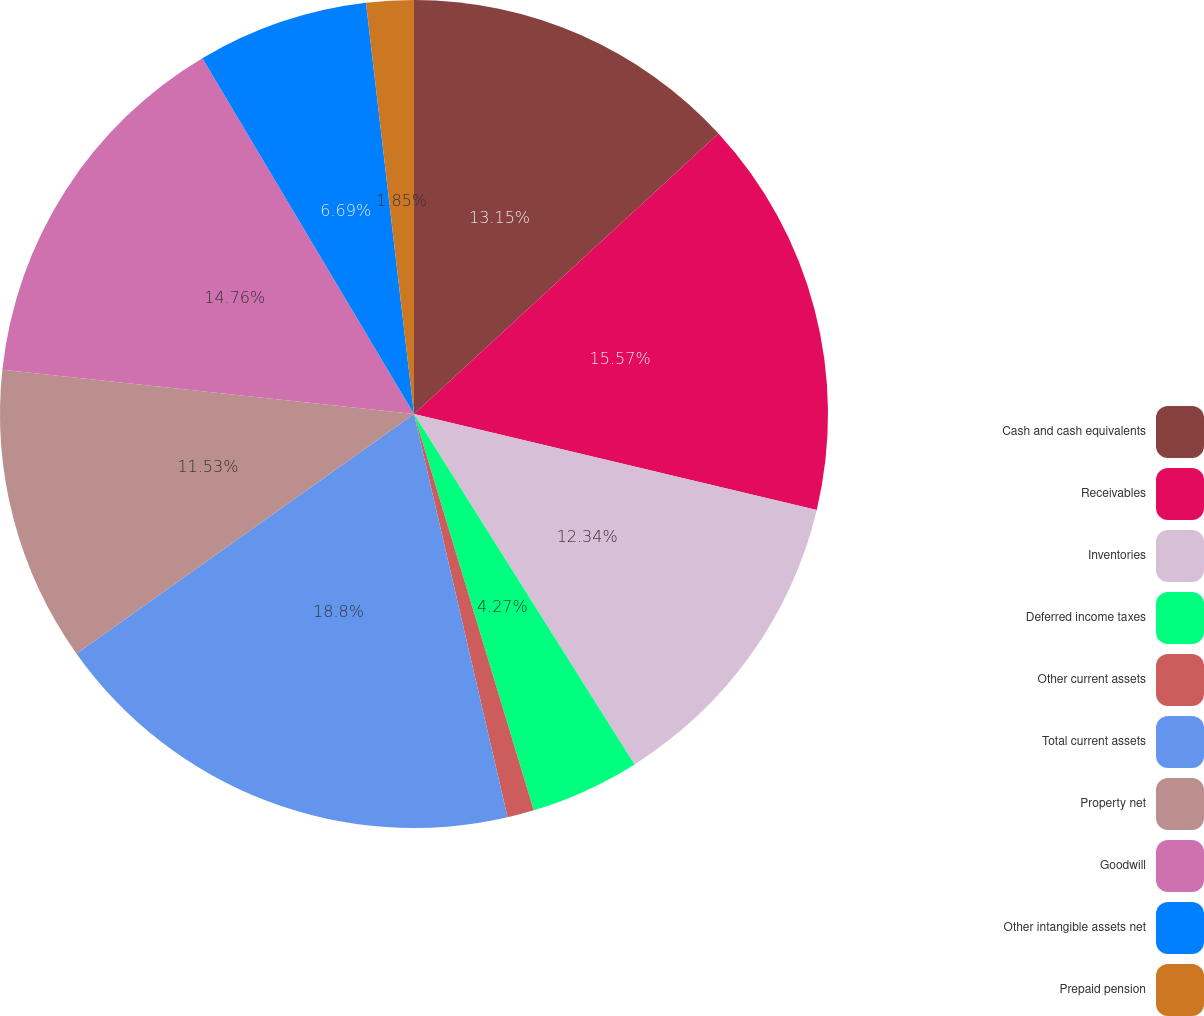<chart> <loc_0><loc_0><loc_500><loc_500><pie_chart><fcel>Cash and cash equivalents<fcel>Receivables<fcel>Inventories<fcel>Deferred income taxes<fcel>Other current assets<fcel>Total current assets<fcel>Property net<fcel>Goodwill<fcel>Other intangible assets net<fcel>Prepaid pension<nl><fcel>13.15%<fcel>15.57%<fcel>12.34%<fcel>4.27%<fcel>1.04%<fcel>18.8%<fcel>11.53%<fcel>14.76%<fcel>6.69%<fcel>1.85%<nl></chart> 